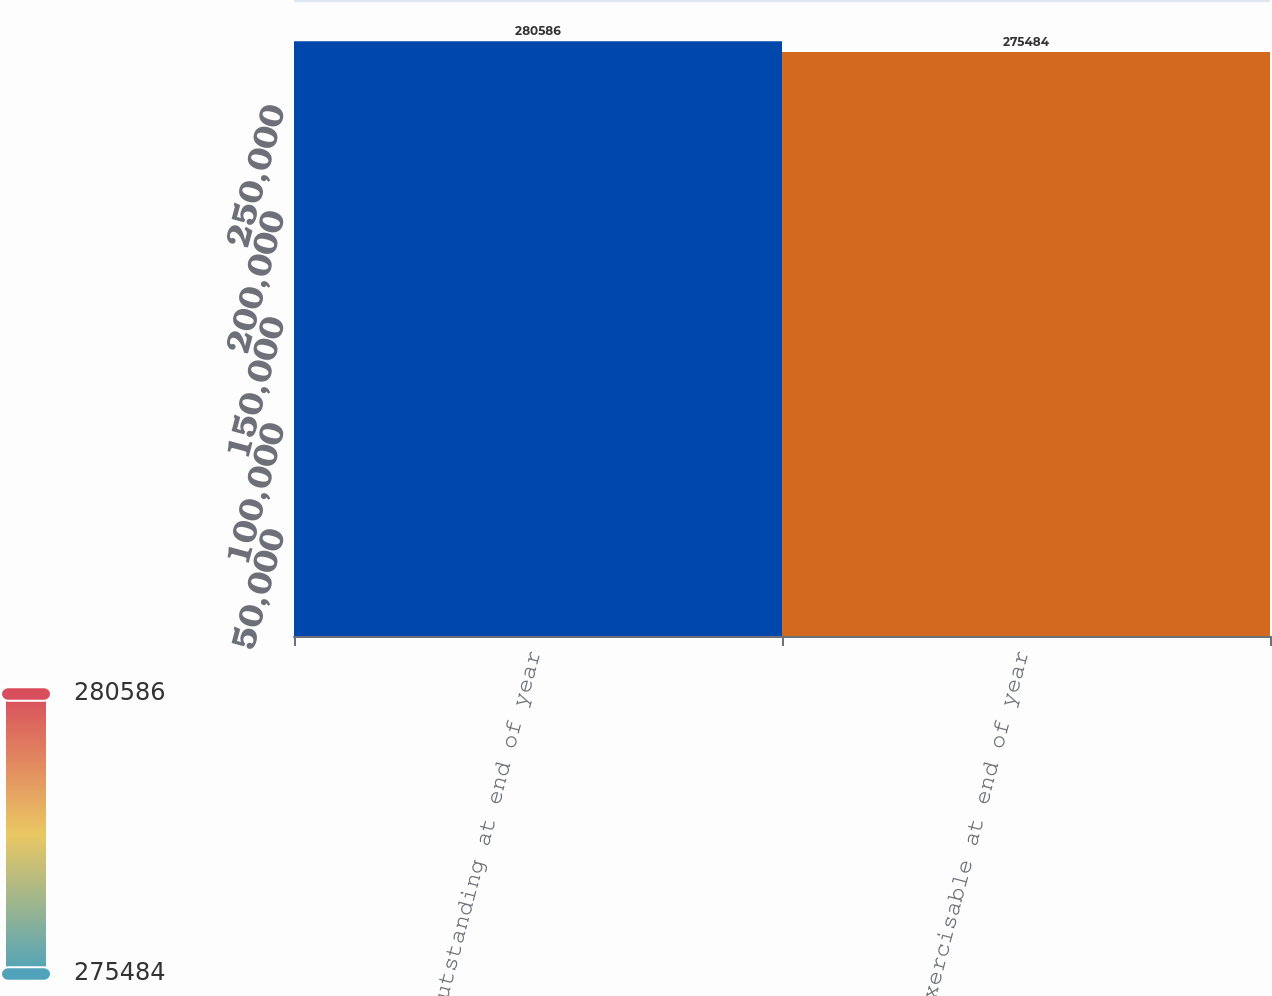Convert chart to OTSL. <chart><loc_0><loc_0><loc_500><loc_500><bar_chart><fcel>Outstanding at end of year<fcel>Exercisable at end of year<nl><fcel>280586<fcel>275484<nl></chart> 